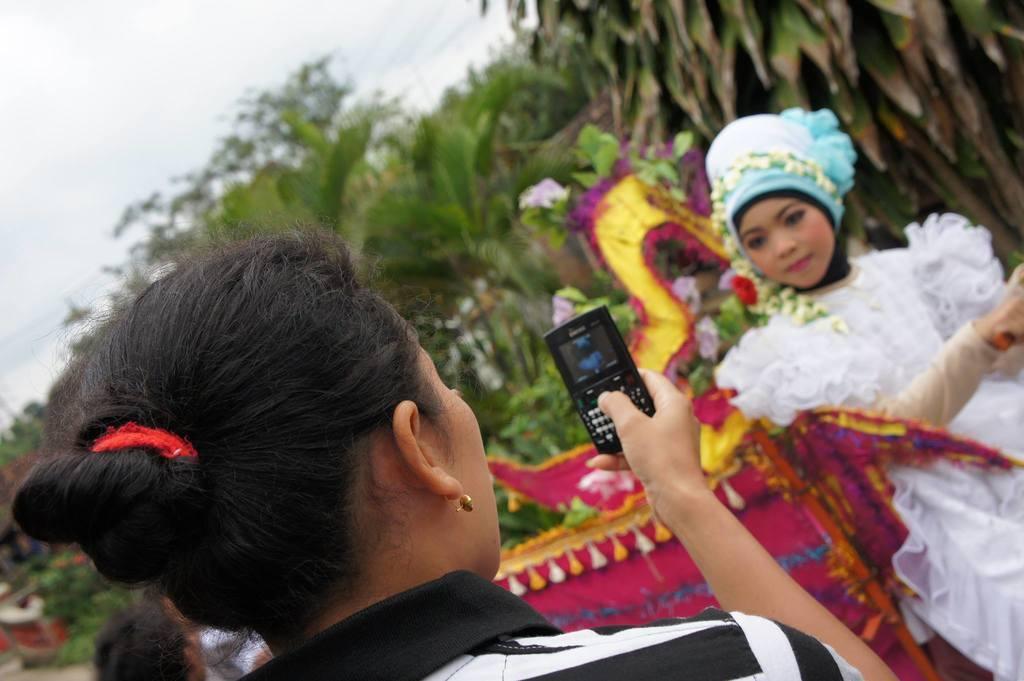Please provide a concise description of this image. Here a woman is trying to take a photograph of another woman in a phone she is posing for the photo. She wear a white color dress behind her there are trees and clouds. 